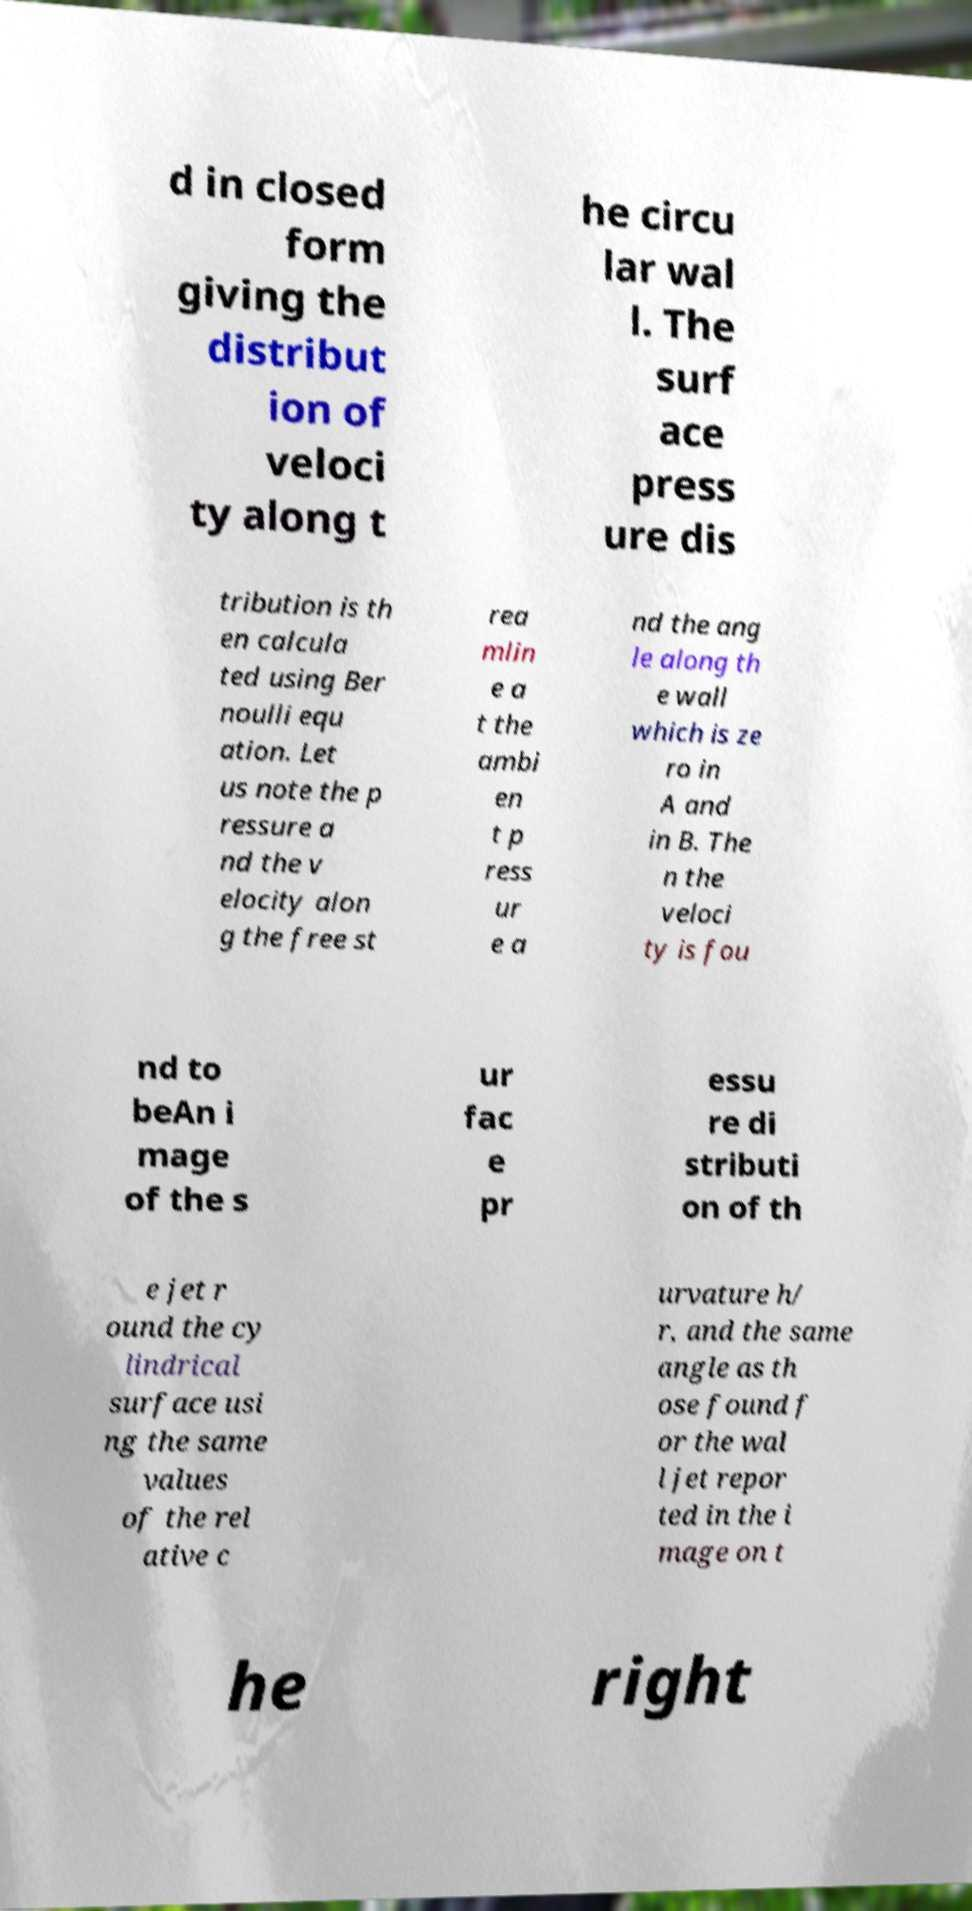Could you extract and type out the text from this image? d in closed form giving the distribut ion of veloci ty along t he circu lar wal l. The surf ace press ure dis tribution is th en calcula ted using Ber noulli equ ation. Let us note the p ressure a nd the v elocity alon g the free st rea mlin e a t the ambi en t p ress ur e a nd the ang le along th e wall which is ze ro in A and in B. The n the veloci ty is fou nd to beAn i mage of the s ur fac e pr essu re di stributi on of th e jet r ound the cy lindrical surface usi ng the same values of the rel ative c urvature h/ r, and the same angle as th ose found f or the wal l jet repor ted in the i mage on t he right 